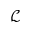Convert formula to latex. <formula><loc_0><loc_0><loc_500><loc_500>\mathcal { L }</formula> 